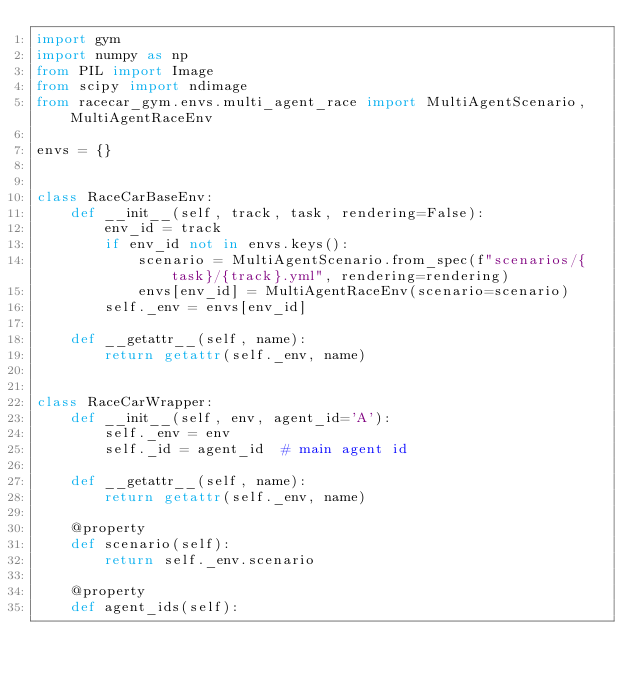<code> <loc_0><loc_0><loc_500><loc_500><_Python_>import gym
import numpy as np
from PIL import Image
from scipy import ndimage
from racecar_gym.envs.multi_agent_race import MultiAgentScenario, MultiAgentRaceEnv

envs = {}


class RaceCarBaseEnv:
    def __init__(self, track, task, rendering=False):
        env_id = track
        if env_id not in envs.keys():
            scenario = MultiAgentScenario.from_spec(f"scenarios/{task}/{track}.yml", rendering=rendering)
            envs[env_id] = MultiAgentRaceEnv(scenario=scenario)
        self._env = envs[env_id]

    def __getattr__(self, name):
        return getattr(self._env, name)


class RaceCarWrapper:
    def __init__(self, env, agent_id='A'):
        self._env = env
        self._id = agent_id  # main agent id

    def __getattr__(self, name):
        return getattr(self._env, name)

    @property
    def scenario(self):
        return self._env.scenario

    @property
    def agent_ids(self):</code> 